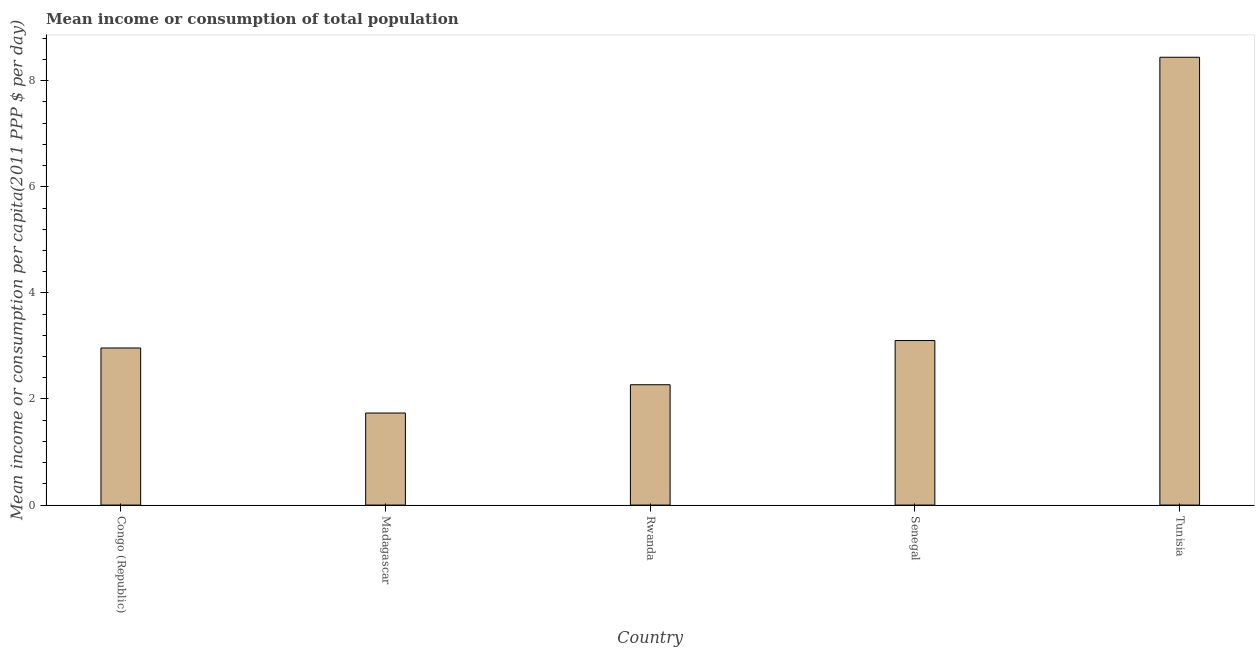Does the graph contain grids?
Your answer should be compact. No. What is the title of the graph?
Provide a succinct answer. Mean income or consumption of total population. What is the label or title of the Y-axis?
Offer a terse response. Mean income or consumption per capita(2011 PPP $ per day). What is the mean income or consumption in Tunisia?
Keep it short and to the point. 8.44. Across all countries, what is the maximum mean income or consumption?
Provide a succinct answer. 8.44. Across all countries, what is the minimum mean income or consumption?
Give a very brief answer. 1.74. In which country was the mean income or consumption maximum?
Offer a very short reply. Tunisia. In which country was the mean income or consumption minimum?
Your response must be concise. Madagascar. What is the sum of the mean income or consumption?
Your response must be concise. 18.51. What is the difference between the mean income or consumption in Congo (Republic) and Tunisia?
Your answer should be compact. -5.48. What is the average mean income or consumption per country?
Ensure brevity in your answer.  3.7. What is the median mean income or consumption?
Give a very brief answer. 2.96. In how many countries, is the mean income or consumption greater than 6.8 $?
Your answer should be very brief. 1. What is the ratio of the mean income or consumption in Madagascar to that in Senegal?
Provide a succinct answer. 0.56. Is the mean income or consumption in Congo (Republic) less than that in Senegal?
Your answer should be very brief. Yes. What is the difference between the highest and the second highest mean income or consumption?
Give a very brief answer. 5.34. Is the sum of the mean income or consumption in Rwanda and Tunisia greater than the maximum mean income or consumption across all countries?
Provide a succinct answer. Yes. What is the difference between the highest and the lowest mean income or consumption?
Keep it short and to the point. 6.71. How many bars are there?
Your response must be concise. 5. Are all the bars in the graph horizontal?
Offer a terse response. No. What is the Mean income or consumption per capita(2011 PPP $ per day) in Congo (Republic)?
Provide a succinct answer. 2.96. What is the Mean income or consumption per capita(2011 PPP $ per day) in Madagascar?
Offer a terse response. 1.74. What is the Mean income or consumption per capita(2011 PPP $ per day) of Rwanda?
Offer a terse response. 2.27. What is the Mean income or consumption per capita(2011 PPP $ per day) of Senegal?
Ensure brevity in your answer.  3.1. What is the Mean income or consumption per capita(2011 PPP $ per day) of Tunisia?
Give a very brief answer. 8.44. What is the difference between the Mean income or consumption per capita(2011 PPP $ per day) in Congo (Republic) and Madagascar?
Keep it short and to the point. 1.23. What is the difference between the Mean income or consumption per capita(2011 PPP $ per day) in Congo (Republic) and Rwanda?
Give a very brief answer. 0.69. What is the difference between the Mean income or consumption per capita(2011 PPP $ per day) in Congo (Republic) and Senegal?
Make the answer very short. -0.14. What is the difference between the Mean income or consumption per capita(2011 PPP $ per day) in Congo (Republic) and Tunisia?
Your answer should be very brief. -5.48. What is the difference between the Mean income or consumption per capita(2011 PPP $ per day) in Madagascar and Rwanda?
Provide a succinct answer. -0.53. What is the difference between the Mean income or consumption per capita(2011 PPP $ per day) in Madagascar and Senegal?
Your response must be concise. -1.37. What is the difference between the Mean income or consumption per capita(2011 PPP $ per day) in Madagascar and Tunisia?
Offer a terse response. -6.71. What is the difference between the Mean income or consumption per capita(2011 PPP $ per day) in Rwanda and Senegal?
Offer a very short reply. -0.83. What is the difference between the Mean income or consumption per capita(2011 PPP $ per day) in Rwanda and Tunisia?
Provide a short and direct response. -6.17. What is the difference between the Mean income or consumption per capita(2011 PPP $ per day) in Senegal and Tunisia?
Ensure brevity in your answer.  -5.34. What is the ratio of the Mean income or consumption per capita(2011 PPP $ per day) in Congo (Republic) to that in Madagascar?
Your response must be concise. 1.71. What is the ratio of the Mean income or consumption per capita(2011 PPP $ per day) in Congo (Republic) to that in Rwanda?
Provide a short and direct response. 1.3. What is the ratio of the Mean income or consumption per capita(2011 PPP $ per day) in Congo (Republic) to that in Senegal?
Your answer should be very brief. 0.95. What is the ratio of the Mean income or consumption per capita(2011 PPP $ per day) in Congo (Republic) to that in Tunisia?
Your answer should be compact. 0.35. What is the ratio of the Mean income or consumption per capita(2011 PPP $ per day) in Madagascar to that in Rwanda?
Make the answer very short. 0.77. What is the ratio of the Mean income or consumption per capita(2011 PPP $ per day) in Madagascar to that in Senegal?
Your answer should be compact. 0.56. What is the ratio of the Mean income or consumption per capita(2011 PPP $ per day) in Madagascar to that in Tunisia?
Provide a short and direct response. 0.21. What is the ratio of the Mean income or consumption per capita(2011 PPP $ per day) in Rwanda to that in Senegal?
Make the answer very short. 0.73. What is the ratio of the Mean income or consumption per capita(2011 PPP $ per day) in Rwanda to that in Tunisia?
Ensure brevity in your answer.  0.27. What is the ratio of the Mean income or consumption per capita(2011 PPP $ per day) in Senegal to that in Tunisia?
Your answer should be very brief. 0.37. 